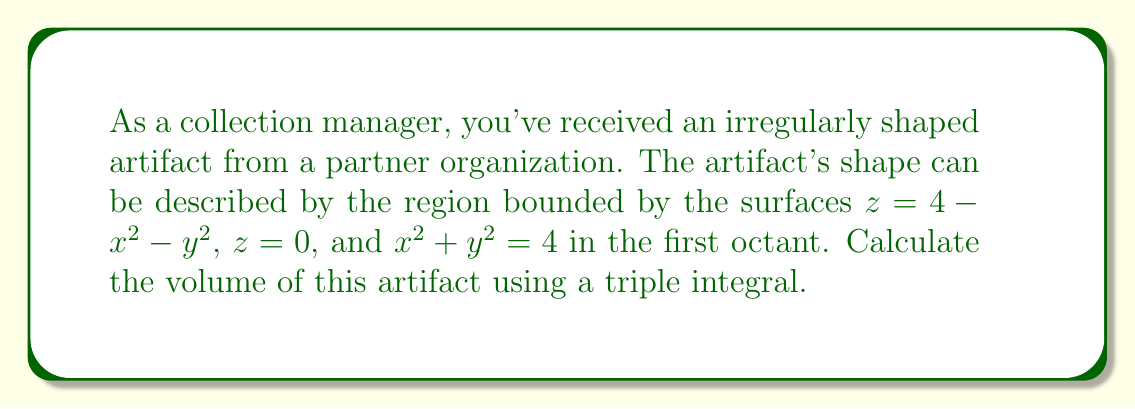Can you answer this question? To determine the volume of this irregularly shaped artifact, we need to set up and evaluate a triple integral. Let's approach this step-by-step:

1) First, we identify the bounds of our integral:
   - In the xy-plane, we're limited by $x^2 + y^2 = 4$ in the first octant, so $0 \leq x \leq 2$ and $0 \leq y \leq \sqrt{4-x^2}$
   - For z, we're bounded between $z = 0$ and $z = 4 - x^2 - y^2$

2) We can now set up our triple integral:

   $$V = \int_0^2 \int_0^{\sqrt{4-x^2}} \int_0^{4-x^2-y^2} 1 \, dz \, dy \, dx$$

3) Let's evaluate the innermost integral first:

   $$V = \int_0^2 \int_0^{\sqrt{4-x^2}} [z]_0^{4-x^2-y^2} \, dy \, dx$$
   $$V = \int_0^2 \int_0^{\sqrt{4-x^2}} (4-x^2-y^2) \, dy \, dx$$

4) Now, let's evaluate the integral with respect to y:

   $$V = \int_0^2 \left[(4-x^2)y - \frac{1}{3}y^3\right]_0^{\sqrt{4-x^2}} \, dx$$
   $$V = \int_0^2 \left((4-x^2)\sqrt{4-x^2} - \frac{1}{3}(4-x^2)^{3/2}\right) \, dx$$

5) This integral is quite complex. Let's use the substitution $x = 2\sin\theta$:
   
   $dx = 2\cos\theta \, d\theta$
   $\sqrt{4-x^2} = 2\cos\theta$
   
   When $x = 0$, $\theta = 0$
   When $x = 2$, $\theta = \pi/2$

   Our integral becomes:

   $$V = \int_0^{\pi/2} \left((4-4\sin^2\theta)(2\cos\theta) - \frac{1}{3}(4\cos^2\theta)^{3/2}\right) 2\cos\theta \, d\theta$$

6) Simplifying:

   $$V = \int_0^{\pi/2} \left(8\cos^2\theta - 8\sin^2\theta\cos\theta - \frac{16}{3}\cos^4\theta\right) \, d\theta$$

7) Using trigonometric identities and evaluating:

   $$V = \left[2\theta + \sin(2\theta) - \frac{2}{3}\sin(4\theta) - \frac{4}{3}\theta\right]_0^{\pi/2}$$
   $$V = \left(\frac{\pi}{2} + 0 - 0 - \frac{2\pi}{3}\right) - (0 + 0 - 0 - 0)$$
   $$V = \frac{\pi}{2} - \frac{2\pi}{3} = \frac{3\pi}{6} - \frac{4\pi}{6} = -\frac{\pi}{6}$$

8) The negative sign is due to our choice of integration order. The actual volume is the absolute value:

   $$V = \frac{\pi}{6}$$
Answer: $\frac{\pi}{6}$ cubic units 